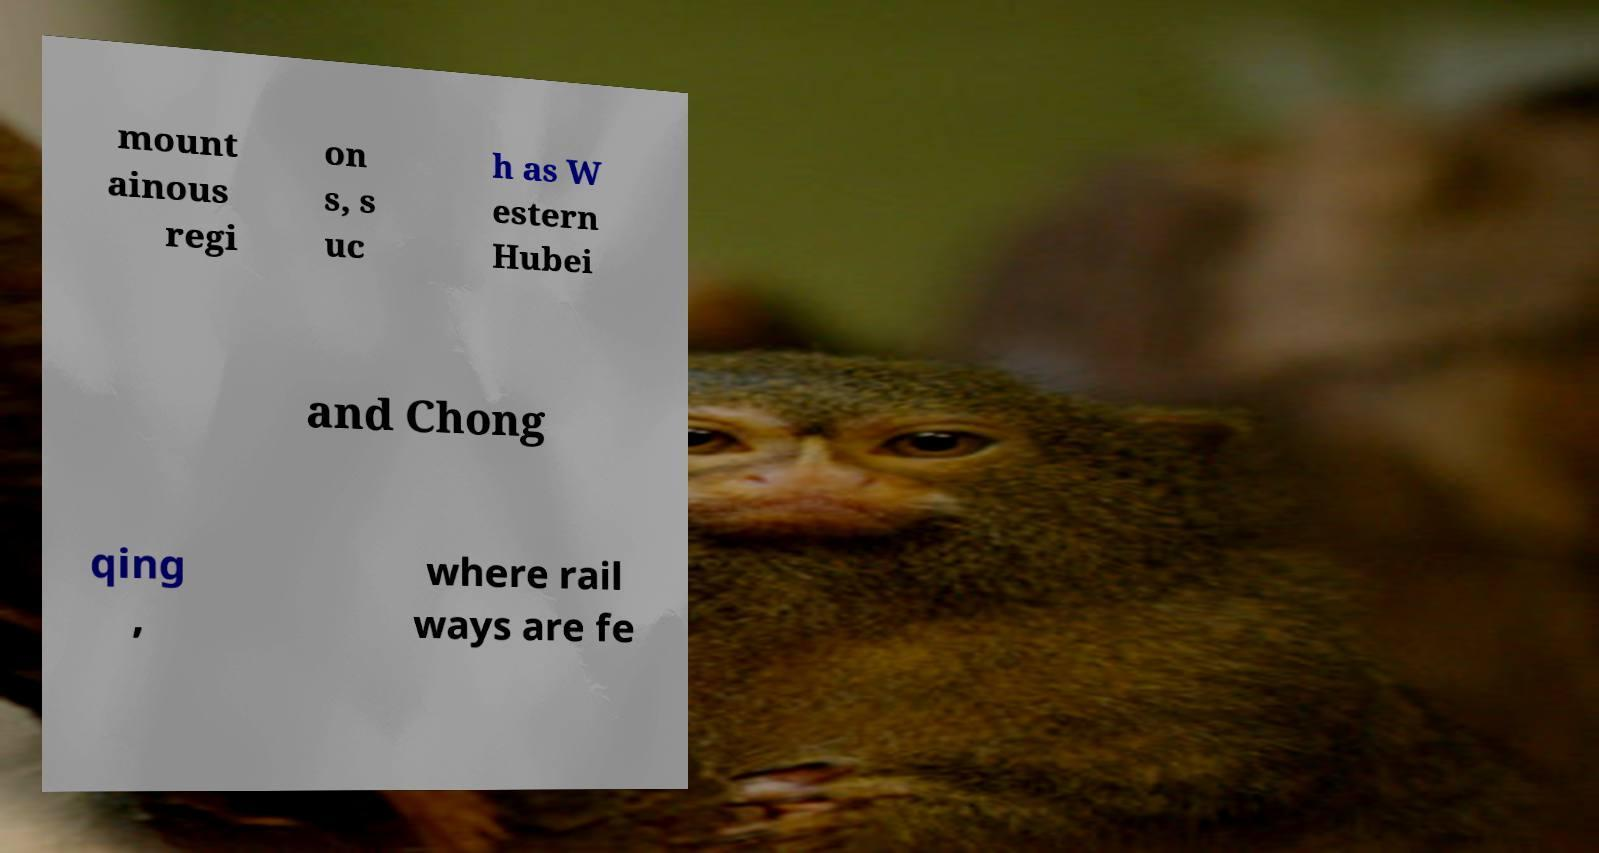Could you assist in decoding the text presented in this image and type it out clearly? mount ainous regi on s, s uc h as W estern Hubei and Chong qing , where rail ways are fe 